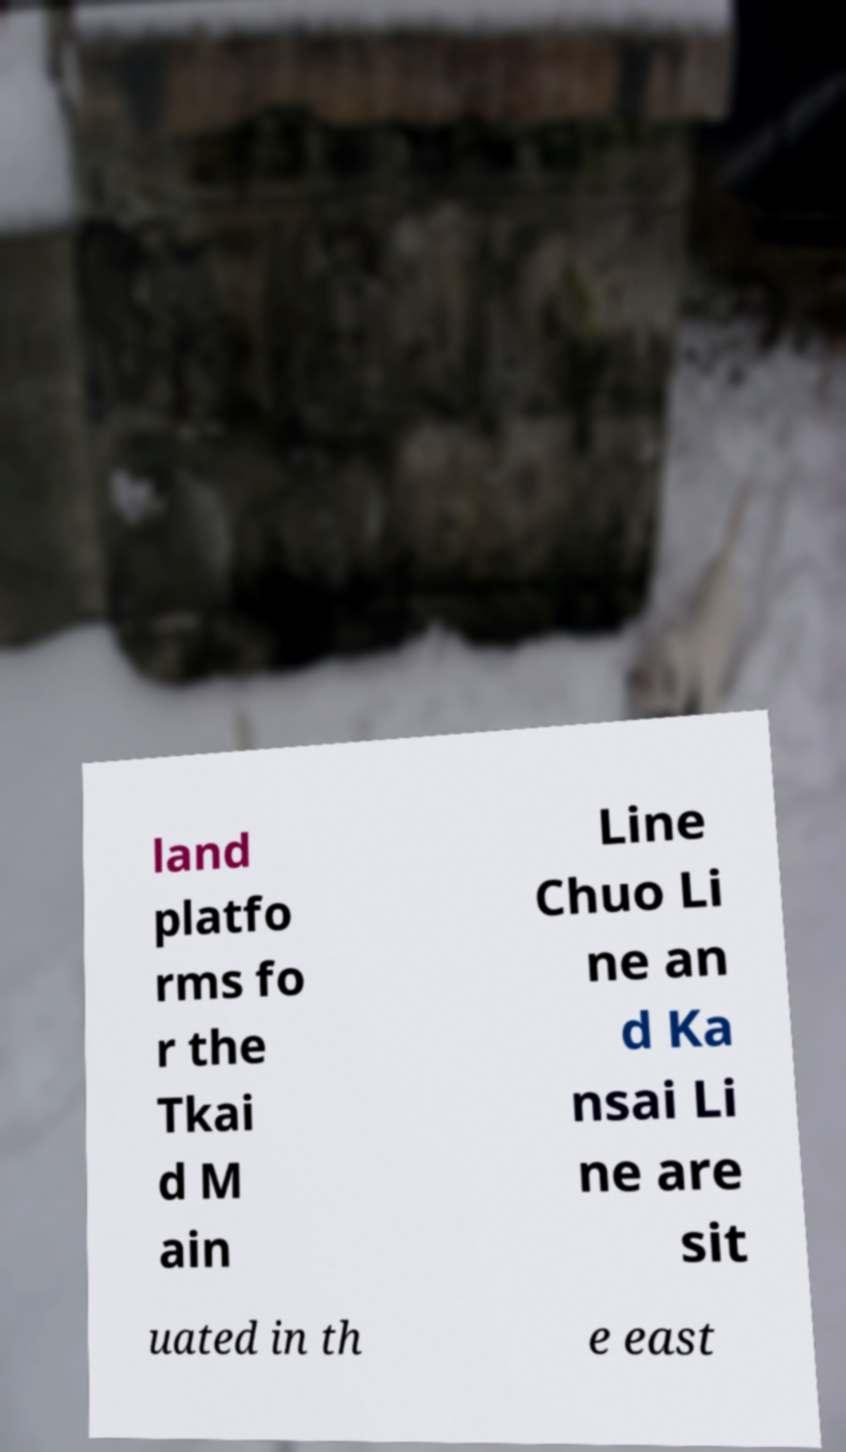There's text embedded in this image that I need extracted. Can you transcribe it verbatim? land platfo rms fo r the Tkai d M ain Line Chuo Li ne an d Ka nsai Li ne are sit uated in th e east 